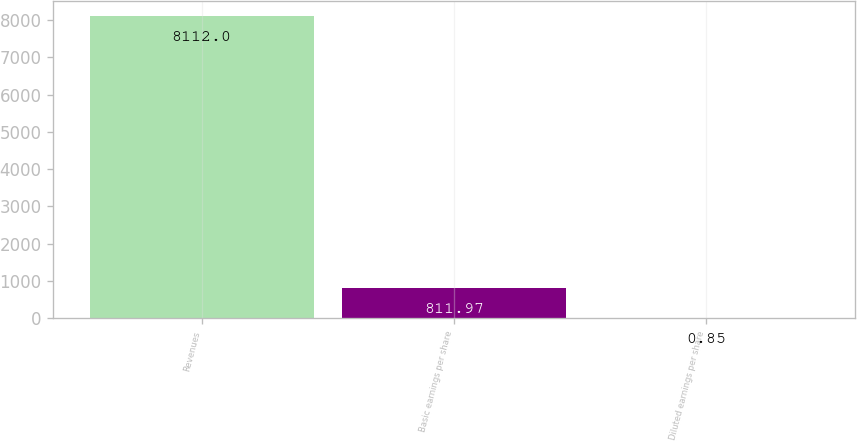Convert chart to OTSL. <chart><loc_0><loc_0><loc_500><loc_500><bar_chart><fcel>Revenues<fcel>Basic earnings per share<fcel>Diluted earnings per share<nl><fcel>8112<fcel>811.97<fcel>0.85<nl></chart> 